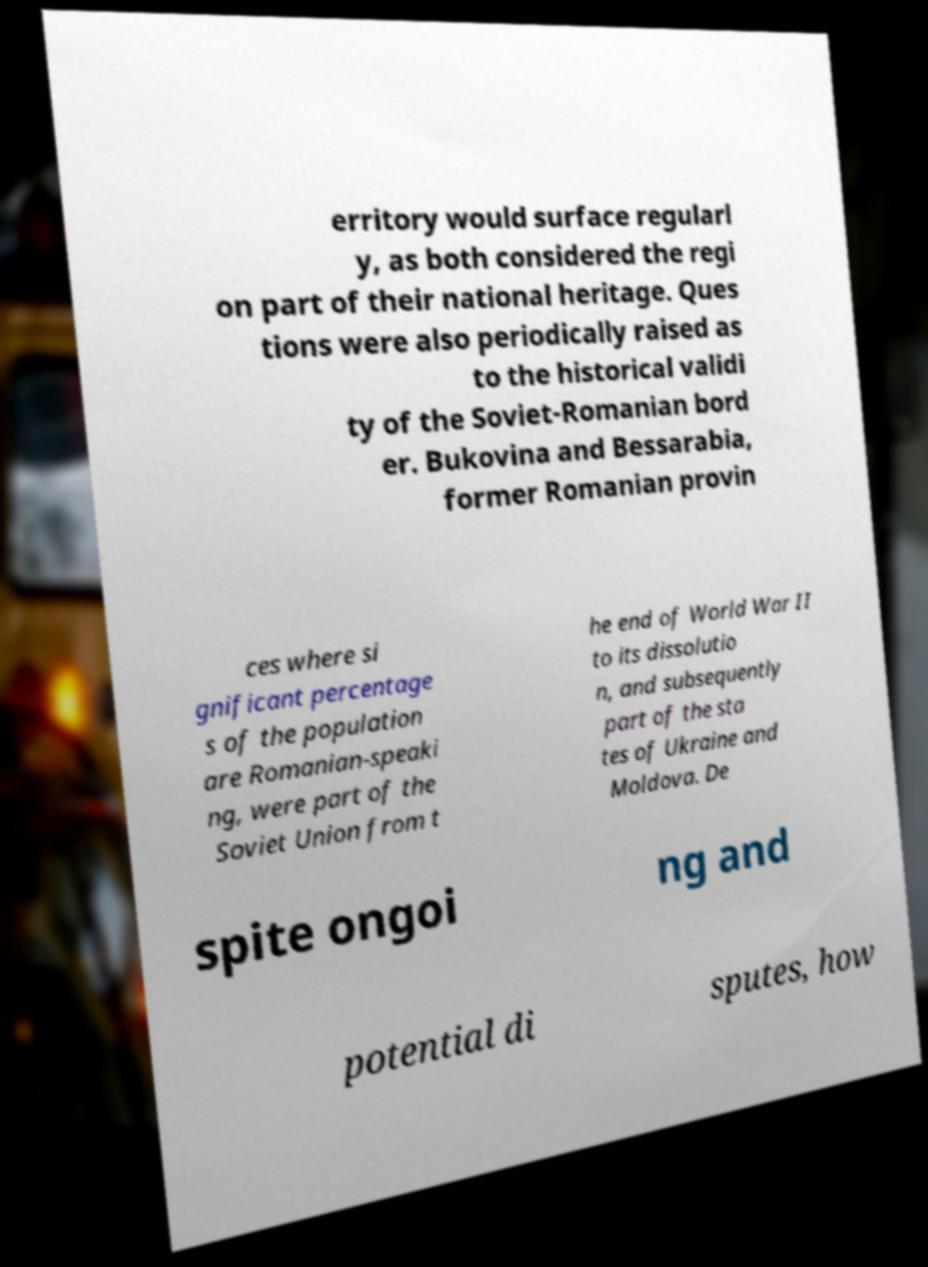For documentation purposes, I need the text within this image transcribed. Could you provide that? erritory would surface regularl y, as both considered the regi on part of their national heritage. Ques tions were also periodically raised as to the historical validi ty of the Soviet-Romanian bord er. Bukovina and Bessarabia, former Romanian provin ces where si gnificant percentage s of the population are Romanian-speaki ng, were part of the Soviet Union from t he end of World War II to its dissolutio n, and subsequently part of the sta tes of Ukraine and Moldova. De spite ongoi ng and potential di sputes, how 